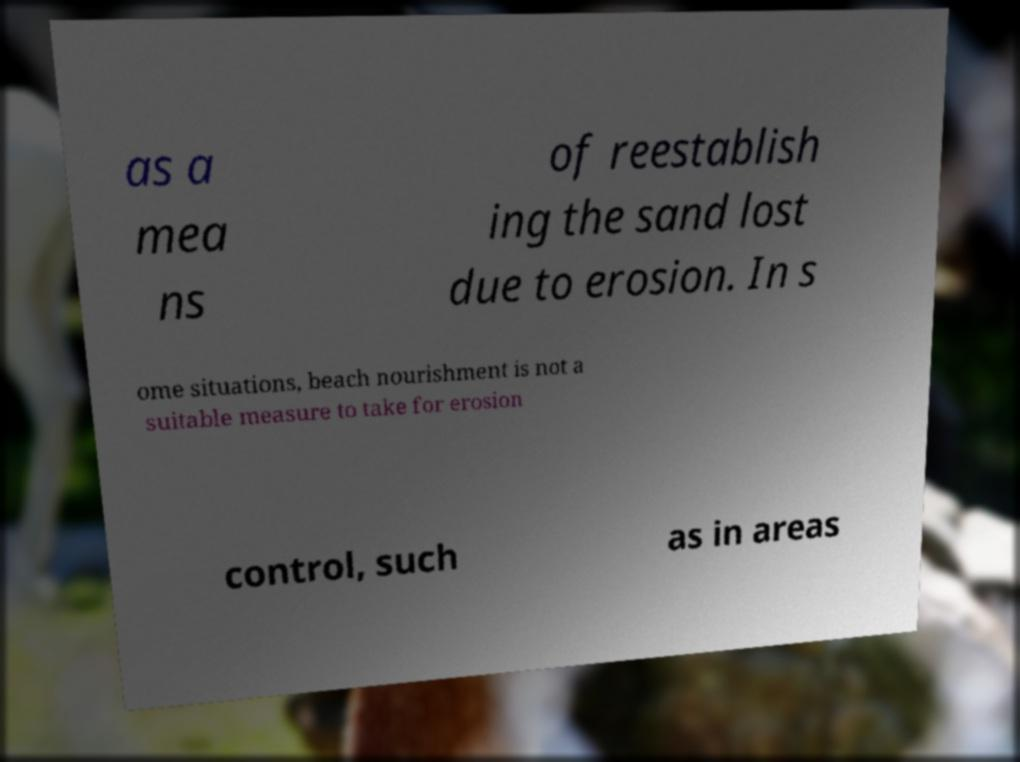There's text embedded in this image that I need extracted. Can you transcribe it verbatim? as a mea ns of reestablish ing the sand lost due to erosion. In s ome situations, beach nourishment is not a suitable measure to take for erosion control, such as in areas 